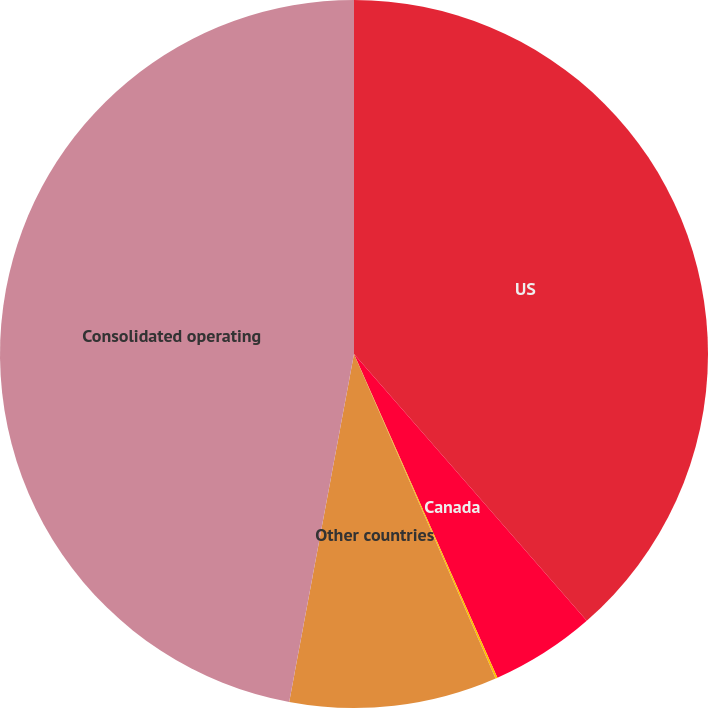Convert chart. <chart><loc_0><loc_0><loc_500><loc_500><pie_chart><fcel>US<fcel>Canada<fcel>UK<fcel>Other countries<fcel>Consolidated operating<nl><fcel>38.58%<fcel>4.78%<fcel>0.09%<fcel>9.48%<fcel>47.07%<nl></chart> 